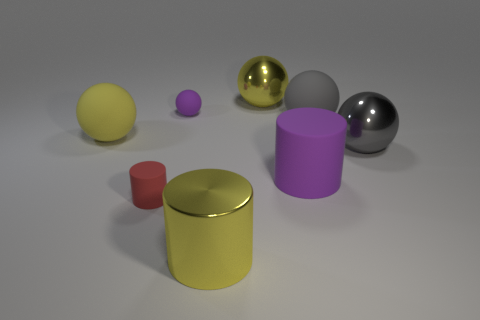Subtract all large cylinders. How many cylinders are left? 1 Subtract all yellow balls. How many balls are left? 3 Subtract all cylinders. How many objects are left? 5 Subtract 1 cylinders. How many cylinders are left? 2 Subtract all brown cylinders. Subtract all tiny purple balls. How many objects are left? 7 Add 2 large metal balls. How many large metal balls are left? 4 Add 7 large gray rubber balls. How many large gray rubber balls exist? 8 Add 2 large yellow spheres. How many objects exist? 10 Subtract 0 brown blocks. How many objects are left? 8 Subtract all brown cylinders. Subtract all brown spheres. How many cylinders are left? 3 